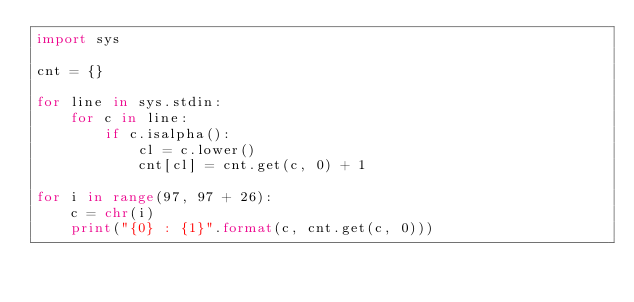<code> <loc_0><loc_0><loc_500><loc_500><_Python_>import sys

cnt = {}

for line in sys.stdin:
    for c in line:
        if c.isalpha():
            cl = c.lower()
            cnt[cl] = cnt.get(c, 0) + 1

for i in range(97, 97 + 26):
    c = chr(i)
    print("{0} : {1}".format(c, cnt.get(c, 0)))
</code> 